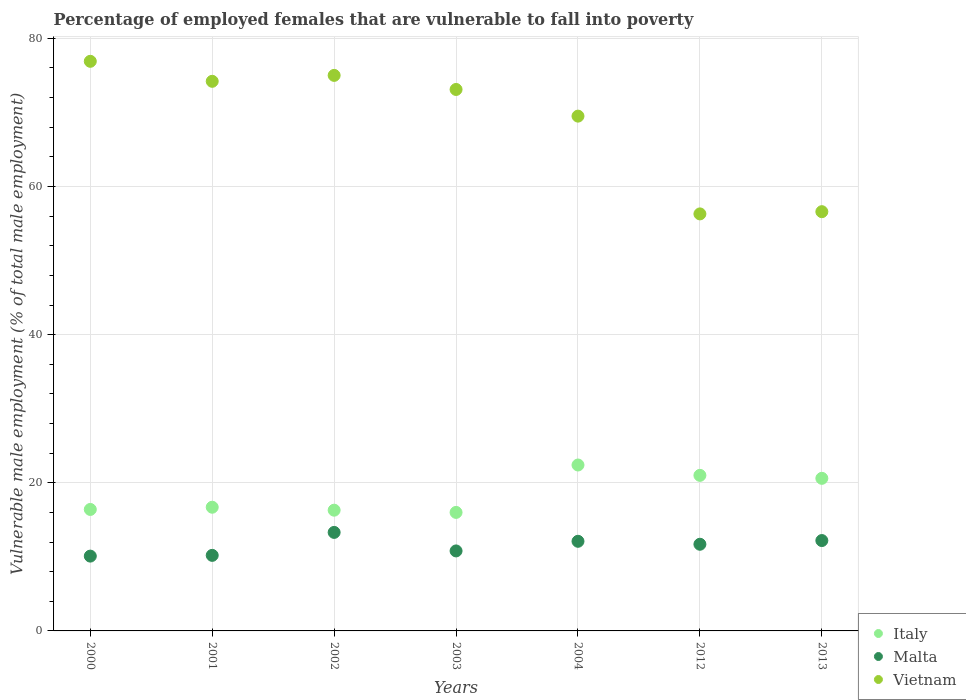What is the percentage of employed females who are vulnerable to fall into poverty in Italy in 2003?
Your response must be concise. 16. Across all years, what is the maximum percentage of employed females who are vulnerable to fall into poverty in Vietnam?
Give a very brief answer. 76.9. Across all years, what is the minimum percentage of employed females who are vulnerable to fall into poverty in Vietnam?
Offer a very short reply. 56.3. In which year was the percentage of employed females who are vulnerable to fall into poverty in Vietnam maximum?
Provide a short and direct response. 2000. In which year was the percentage of employed females who are vulnerable to fall into poverty in Malta minimum?
Your answer should be compact. 2000. What is the total percentage of employed females who are vulnerable to fall into poverty in Malta in the graph?
Ensure brevity in your answer.  80.4. What is the difference between the percentage of employed females who are vulnerable to fall into poverty in Malta in 2001 and that in 2013?
Ensure brevity in your answer.  -2. What is the difference between the percentage of employed females who are vulnerable to fall into poverty in Vietnam in 2013 and the percentage of employed females who are vulnerable to fall into poverty in Malta in 2000?
Your answer should be very brief. 46.5. What is the average percentage of employed females who are vulnerable to fall into poverty in Italy per year?
Offer a terse response. 18.49. In the year 2001, what is the difference between the percentage of employed females who are vulnerable to fall into poverty in Malta and percentage of employed females who are vulnerable to fall into poverty in Italy?
Your response must be concise. -6.5. In how many years, is the percentage of employed females who are vulnerable to fall into poverty in Vietnam greater than 24 %?
Give a very brief answer. 7. What is the ratio of the percentage of employed females who are vulnerable to fall into poverty in Italy in 2012 to that in 2013?
Offer a very short reply. 1.02. Is the percentage of employed females who are vulnerable to fall into poverty in Italy in 2012 less than that in 2013?
Offer a terse response. No. What is the difference between the highest and the second highest percentage of employed females who are vulnerable to fall into poverty in Italy?
Your answer should be compact. 1.4. What is the difference between the highest and the lowest percentage of employed females who are vulnerable to fall into poverty in Vietnam?
Give a very brief answer. 20.6. In how many years, is the percentage of employed females who are vulnerable to fall into poverty in Vietnam greater than the average percentage of employed females who are vulnerable to fall into poverty in Vietnam taken over all years?
Ensure brevity in your answer.  5. Is it the case that in every year, the sum of the percentage of employed females who are vulnerable to fall into poverty in Malta and percentage of employed females who are vulnerable to fall into poverty in Vietnam  is greater than the percentage of employed females who are vulnerable to fall into poverty in Italy?
Give a very brief answer. Yes. Does the percentage of employed females who are vulnerable to fall into poverty in Italy monotonically increase over the years?
Give a very brief answer. No. Is the percentage of employed females who are vulnerable to fall into poverty in Vietnam strictly less than the percentage of employed females who are vulnerable to fall into poverty in Malta over the years?
Keep it short and to the point. No. How many dotlines are there?
Give a very brief answer. 3. How many years are there in the graph?
Ensure brevity in your answer.  7. What is the difference between two consecutive major ticks on the Y-axis?
Provide a succinct answer. 20. Does the graph contain any zero values?
Make the answer very short. No. Does the graph contain grids?
Ensure brevity in your answer.  Yes. How many legend labels are there?
Offer a very short reply. 3. How are the legend labels stacked?
Ensure brevity in your answer.  Vertical. What is the title of the graph?
Offer a very short reply. Percentage of employed females that are vulnerable to fall into poverty. What is the label or title of the X-axis?
Make the answer very short. Years. What is the label or title of the Y-axis?
Give a very brief answer. Vulnerable male employment (% of total male employment). What is the Vulnerable male employment (% of total male employment) in Italy in 2000?
Make the answer very short. 16.4. What is the Vulnerable male employment (% of total male employment) of Malta in 2000?
Give a very brief answer. 10.1. What is the Vulnerable male employment (% of total male employment) of Vietnam in 2000?
Ensure brevity in your answer.  76.9. What is the Vulnerable male employment (% of total male employment) of Italy in 2001?
Offer a terse response. 16.7. What is the Vulnerable male employment (% of total male employment) of Malta in 2001?
Offer a terse response. 10.2. What is the Vulnerable male employment (% of total male employment) in Vietnam in 2001?
Keep it short and to the point. 74.2. What is the Vulnerable male employment (% of total male employment) in Italy in 2002?
Your answer should be compact. 16.3. What is the Vulnerable male employment (% of total male employment) of Malta in 2002?
Your answer should be compact. 13.3. What is the Vulnerable male employment (% of total male employment) of Vietnam in 2002?
Your response must be concise. 75. What is the Vulnerable male employment (% of total male employment) in Italy in 2003?
Ensure brevity in your answer.  16. What is the Vulnerable male employment (% of total male employment) of Malta in 2003?
Give a very brief answer. 10.8. What is the Vulnerable male employment (% of total male employment) of Vietnam in 2003?
Give a very brief answer. 73.1. What is the Vulnerable male employment (% of total male employment) of Italy in 2004?
Your response must be concise. 22.4. What is the Vulnerable male employment (% of total male employment) of Malta in 2004?
Your answer should be compact. 12.1. What is the Vulnerable male employment (% of total male employment) of Vietnam in 2004?
Offer a terse response. 69.5. What is the Vulnerable male employment (% of total male employment) in Italy in 2012?
Ensure brevity in your answer.  21. What is the Vulnerable male employment (% of total male employment) in Malta in 2012?
Your response must be concise. 11.7. What is the Vulnerable male employment (% of total male employment) of Vietnam in 2012?
Your answer should be very brief. 56.3. What is the Vulnerable male employment (% of total male employment) of Italy in 2013?
Provide a succinct answer. 20.6. What is the Vulnerable male employment (% of total male employment) in Malta in 2013?
Keep it short and to the point. 12.2. What is the Vulnerable male employment (% of total male employment) of Vietnam in 2013?
Provide a short and direct response. 56.6. Across all years, what is the maximum Vulnerable male employment (% of total male employment) in Italy?
Your response must be concise. 22.4. Across all years, what is the maximum Vulnerable male employment (% of total male employment) of Malta?
Give a very brief answer. 13.3. Across all years, what is the maximum Vulnerable male employment (% of total male employment) of Vietnam?
Offer a terse response. 76.9. Across all years, what is the minimum Vulnerable male employment (% of total male employment) of Malta?
Provide a short and direct response. 10.1. Across all years, what is the minimum Vulnerable male employment (% of total male employment) of Vietnam?
Your response must be concise. 56.3. What is the total Vulnerable male employment (% of total male employment) of Italy in the graph?
Your answer should be very brief. 129.4. What is the total Vulnerable male employment (% of total male employment) of Malta in the graph?
Offer a very short reply. 80.4. What is the total Vulnerable male employment (% of total male employment) in Vietnam in the graph?
Keep it short and to the point. 481.6. What is the difference between the Vulnerable male employment (% of total male employment) of Italy in 2000 and that in 2001?
Ensure brevity in your answer.  -0.3. What is the difference between the Vulnerable male employment (% of total male employment) of Vietnam in 2000 and that in 2001?
Your response must be concise. 2.7. What is the difference between the Vulnerable male employment (% of total male employment) of Italy in 2000 and that in 2002?
Your answer should be very brief. 0.1. What is the difference between the Vulnerable male employment (% of total male employment) in Italy in 2000 and that in 2003?
Keep it short and to the point. 0.4. What is the difference between the Vulnerable male employment (% of total male employment) of Malta in 2000 and that in 2003?
Ensure brevity in your answer.  -0.7. What is the difference between the Vulnerable male employment (% of total male employment) in Vietnam in 2000 and that in 2003?
Offer a terse response. 3.8. What is the difference between the Vulnerable male employment (% of total male employment) of Malta in 2000 and that in 2004?
Your answer should be compact. -2. What is the difference between the Vulnerable male employment (% of total male employment) in Italy in 2000 and that in 2012?
Your answer should be compact. -4.6. What is the difference between the Vulnerable male employment (% of total male employment) of Vietnam in 2000 and that in 2012?
Offer a terse response. 20.6. What is the difference between the Vulnerable male employment (% of total male employment) of Vietnam in 2000 and that in 2013?
Your answer should be compact. 20.3. What is the difference between the Vulnerable male employment (% of total male employment) in Italy in 2001 and that in 2002?
Your answer should be compact. 0.4. What is the difference between the Vulnerable male employment (% of total male employment) in Vietnam in 2001 and that in 2002?
Provide a succinct answer. -0.8. What is the difference between the Vulnerable male employment (% of total male employment) of Italy in 2001 and that in 2003?
Make the answer very short. 0.7. What is the difference between the Vulnerable male employment (% of total male employment) in Vietnam in 2001 and that in 2003?
Offer a very short reply. 1.1. What is the difference between the Vulnerable male employment (% of total male employment) of Malta in 2001 and that in 2004?
Ensure brevity in your answer.  -1.9. What is the difference between the Vulnerable male employment (% of total male employment) of Vietnam in 2001 and that in 2012?
Make the answer very short. 17.9. What is the difference between the Vulnerable male employment (% of total male employment) in Italy in 2001 and that in 2013?
Provide a short and direct response. -3.9. What is the difference between the Vulnerable male employment (% of total male employment) of Malta in 2001 and that in 2013?
Ensure brevity in your answer.  -2. What is the difference between the Vulnerable male employment (% of total male employment) in Italy in 2002 and that in 2003?
Offer a very short reply. 0.3. What is the difference between the Vulnerable male employment (% of total male employment) of Vietnam in 2002 and that in 2003?
Give a very brief answer. 1.9. What is the difference between the Vulnerable male employment (% of total male employment) of Italy in 2002 and that in 2004?
Give a very brief answer. -6.1. What is the difference between the Vulnerable male employment (% of total male employment) of Vietnam in 2002 and that in 2012?
Ensure brevity in your answer.  18.7. What is the difference between the Vulnerable male employment (% of total male employment) in Italy in 2002 and that in 2013?
Your response must be concise. -4.3. What is the difference between the Vulnerable male employment (% of total male employment) in Malta in 2002 and that in 2013?
Offer a very short reply. 1.1. What is the difference between the Vulnerable male employment (% of total male employment) of Vietnam in 2002 and that in 2013?
Your answer should be compact. 18.4. What is the difference between the Vulnerable male employment (% of total male employment) of Italy in 2003 and that in 2004?
Your answer should be compact. -6.4. What is the difference between the Vulnerable male employment (% of total male employment) in Malta in 2003 and that in 2004?
Your response must be concise. -1.3. What is the difference between the Vulnerable male employment (% of total male employment) of Vietnam in 2003 and that in 2012?
Your answer should be compact. 16.8. What is the difference between the Vulnerable male employment (% of total male employment) in Italy in 2003 and that in 2013?
Your response must be concise. -4.6. What is the difference between the Vulnerable male employment (% of total male employment) of Malta in 2003 and that in 2013?
Your response must be concise. -1.4. What is the difference between the Vulnerable male employment (% of total male employment) of Vietnam in 2003 and that in 2013?
Provide a succinct answer. 16.5. What is the difference between the Vulnerable male employment (% of total male employment) of Malta in 2004 and that in 2012?
Ensure brevity in your answer.  0.4. What is the difference between the Vulnerable male employment (% of total male employment) of Italy in 2004 and that in 2013?
Your answer should be very brief. 1.8. What is the difference between the Vulnerable male employment (% of total male employment) in Vietnam in 2004 and that in 2013?
Make the answer very short. 12.9. What is the difference between the Vulnerable male employment (% of total male employment) of Malta in 2012 and that in 2013?
Give a very brief answer. -0.5. What is the difference between the Vulnerable male employment (% of total male employment) of Vietnam in 2012 and that in 2013?
Your response must be concise. -0.3. What is the difference between the Vulnerable male employment (% of total male employment) of Italy in 2000 and the Vulnerable male employment (% of total male employment) of Malta in 2001?
Give a very brief answer. 6.2. What is the difference between the Vulnerable male employment (% of total male employment) in Italy in 2000 and the Vulnerable male employment (% of total male employment) in Vietnam in 2001?
Your answer should be very brief. -57.8. What is the difference between the Vulnerable male employment (% of total male employment) in Malta in 2000 and the Vulnerable male employment (% of total male employment) in Vietnam in 2001?
Offer a terse response. -64.1. What is the difference between the Vulnerable male employment (% of total male employment) in Italy in 2000 and the Vulnerable male employment (% of total male employment) in Malta in 2002?
Provide a succinct answer. 3.1. What is the difference between the Vulnerable male employment (% of total male employment) of Italy in 2000 and the Vulnerable male employment (% of total male employment) of Vietnam in 2002?
Offer a very short reply. -58.6. What is the difference between the Vulnerable male employment (% of total male employment) in Malta in 2000 and the Vulnerable male employment (% of total male employment) in Vietnam in 2002?
Ensure brevity in your answer.  -64.9. What is the difference between the Vulnerable male employment (% of total male employment) of Italy in 2000 and the Vulnerable male employment (% of total male employment) of Malta in 2003?
Your answer should be very brief. 5.6. What is the difference between the Vulnerable male employment (% of total male employment) of Italy in 2000 and the Vulnerable male employment (% of total male employment) of Vietnam in 2003?
Provide a succinct answer. -56.7. What is the difference between the Vulnerable male employment (% of total male employment) in Malta in 2000 and the Vulnerable male employment (% of total male employment) in Vietnam in 2003?
Provide a short and direct response. -63. What is the difference between the Vulnerable male employment (% of total male employment) in Italy in 2000 and the Vulnerable male employment (% of total male employment) in Vietnam in 2004?
Give a very brief answer. -53.1. What is the difference between the Vulnerable male employment (% of total male employment) of Malta in 2000 and the Vulnerable male employment (% of total male employment) of Vietnam in 2004?
Provide a succinct answer. -59.4. What is the difference between the Vulnerable male employment (% of total male employment) in Italy in 2000 and the Vulnerable male employment (% of total male employment) in Malta in 2012?
Ensure brevity in your answer.  4.7. What is the difference between the Vulnerable male employment (% of total male employment) of Italy in 2000 and the Vulnerable male employment (% of total male employment) of Vietnam in 2012?
Give a very brief answer. -39.9. What is the difference between the Vulnerable male employment (% of total male employment) of Malta in 2000 and the Vulnerable male employment (% of total male employment) of Vietnam in 2012?
Your answer should be very brief. -46.2. What is the difference between the Vulnerable male employment (% of total male employment) of Italy in 2000 and the Vulnerable male employment (% of total male employment) of Vietnam in 2013?
Provide a succinct answer. -40.2. What is the difference between the Vulnerable male employment (% of total male employment) in Malta in 2000 and the Vulnerable male employment (% of total male employment) in Vietnam in 2013?
Make the answer very short. -46.5. What is the difference between the Vulnerable male employment (% of total male employment) of Italy in 2001 and the Vulnerable male employment (% of total male employment) of Vietnam in 2002?
Offer a very short reply. -58.3. What is the difference between the Vulnerable male employment (% of total male employment) of Malta in 2001 and the Vulnerable male employment (% of total male employment) of Vietnam in 2002?
Your answer should be compact. -64.8. What is the difference between the Vulnerable male employment (% of total male employment) in Italy in 2001 and the Vulnerable male employment (% of total male employment) in Malta in 2003?
Your response must be concise. 5.9. What is the difference between the Vulnerable male employment (% of total male employment) of Italy in 2001 and the Vulnerable male employment (% of total male employment) of Vietnam in 2003?
Give a very brief answer. -56.4. What is the difference between the Vulnerable male employment (% of total male employment) of Malta in 2001 and the Vulnerable male employment (% of total male employment) of Vietnam in 2003?
Offer a terse response. -62.9. What is the difference between the Vulnerable male employment (% of total male employment) in Italy in 2001 and the Vulnerable male employment (% of total male employment) in Vietnam in 2004?
Make the answer very short. -52.8. What is the difference between the Vulnerable male employment (% of total male employment) of Malta in 2001 and the Vulnerable male employment (% of total male employment) of Vietnam in 2004?
Give a very brief answer. -59.3. What is the difference between the Vulnerable male employment (% of total male employment) of Italy in 2001 and the Vulnerable male employment (% of total male employment) of Malta in 2012?
Provide a succinct answer. 5. What is the difference between the Vulnerable male employment (% of total male employment) in Italy in 2001 and the Vulnerable male employment (% of total male employment) in Vietnam in 2012?
Your response must be concise. -39.6. What is the difference between the Vulnerable male employment (% of total male employment) of Malta in 2001 and the Vulnerable male employment (% of total male employment) of Vietnam in 2012?
Your response must be concise. -46.1. What is the difference between the Vulnerable male employment (% of total male employment) in Italy in 2001 and the Vulnerable male employment (% of total male employment) in Vietnam in 2013?
Your response must be concise. -39.9. What is the difference between the Vulnerable male employment (% of total male employment) of Malta in 2001 and the Vulnerable male employment (% of total male employment) of Vietnam in 2013?
Ensure brevity in your answer.  -46.4. What is the difference between the Vulnerable male employment (% of total male employment) of Italy in 2002 and the Vulnerable male employment (% of total male employment) of Vietnam in 2003?
Make the answer very short. -56.8. What is the difference between the Vulnerable male employment (% of total male employment) of Malta in 2002 and the Vulnerable male employment (% of total male employment) of Vietnam in 2003?
Ensure brevity in your answer.  -59.8. What is the difference between the Vulnerable male employment (% of total male employment) in Italy in 2002 and the Vulnerable male employment (% of total male employment) in Malta in 2004?
Your response must be concise. 4.2. What is the difference between the Vulnerable male employment (% of total male employment) of Italy in 2002 and the Vulnerable male employment (% of total male employment) of Vietnam in 2004?
Make the answer very short. -53.2. What is the difference between the Vulnerable male employment (% of total male employment) of Malta in 2002 and the Vulnerable male employment (% of total male employment) of Vietnam in 2004?
Ensure brevity in your answer.  -56.2. What is the difference between the Vulnerable male employment (% of total male employment) of Italy in 2002 and the Vulnerable male employment (% of total male employment) of Malta in 2012?
Give a very brief answer. 4.6. What is the difference between the Vulnerable male employment (% of total male employment) in Malta in 2002 and the Vulnerable male employment (% of total male employment) in Vietnam in 2012?
Ensure brevity in your answer.  -43. What is the difference between the Vulnerable male employment (% of total male employment) in Italy in 2002 and the Vulnerable male employment (% of total male employment) in Malta in 2013?
Offer a very short reply. 4.1. What is the difference between the Vulnerable male employment (% of total male employment) in Italy in 2002 and the Vulnerable male employment (% of total male employment) in Vietnam in 2013?
Make the answer very short. -40.3. What is the difference between the Vulnerable male employment (% of total male employment) in Malta in 2002 and the Vulnerable male employment (% of total male employment) in Vietnam in 2013?
Provide a succinct answer. -43.3. What is the difference between the Vulnerable male employment (% of total male employment) in Italy in 2003 and the Vulnerable male employment (% of total male employment) in Malta in 2004?
Provide a short and direct response. 3.9. What is the difference between the Vulnerable male employment (% of total male employment) of Italy in 2003 and the Vulnerable male employment (% of total male employment) of Vietnam in 2004?
Make the answer very short. -53.5. What is the difference between the Vulnerable male employment (% of total male employment) of Malta in 2003 and the Vulnerable male employment (% of total male employment) of Vietnam in 2004?
Offer a very short reply. -58.7. What is the difference between the Vulnerable male employment (% of total male employment) of Italy in 2003 and the Vulnerable male employment (% of total male employment) of Vietnam in 2012?
Offer a terse response. -40.3. What is the difference between the Vulnerable male employment (% of total male employment) of Malta in 2003 and the Vulnerable male employment (% of total male employment) of Vietnam in 2012?
Provide a succinct answer. -45.5. What is the difference between the Vulnerable male employment (% of total male employment) of Italy in 2003 and the Vulnerable male employment (% of total male employment) of Vietnam in 2013?
Provide a short and direct response. -40.6. What is the difference between the Vulnerable male employment (% of total male employment) of Malta in 2003 and the Vulnerable male employment (% of total male employment) of Vietnam in 2013?
Provide a short and direct response. -45.8. What is the difference between the Vulnerable male employment (% of total male employment) in Italy in 2004 and the Vulnerable male employment (% of total male employment) in Vietnam in 2012?
Your answer should be very brief. -33.9. What is the difference between the Vulnerable male employment (% of total male employment) of Malta in 2004 and the Vulnerable male employment (% of total male employment) of Vietnam in 2012?
Provide a succinct answer. -44.2. What is the difference between the Vulnerable male employment (% of total male employment) in Italy in 2004 and the Vulnerable male employment (% of total male employment) in Malta in 2013?
Keep it short and to the point. 10.2. What is the difference between the Vulnerable male employment (% of total male employment) in Italy in 2004 and the Vulnerable male employment (% of total male employment) in Vietnam in 2013?
Keep it short and to the point. -34.2. What is the difference between the Vulnerable male employment (% of total male employment) of Malta in 2004 and the Vulnerable male employment (% of total male employment) of Vietnam in 2013?
Ensure brevity in your answer.  -44.5. What is the difference between the Vulnerable male employment (% of total male employment) of Italy in 2012 and the Vulnerable male employment (% of total male employment) of Malta in 2013?
Your answer should be very brief. 8.8. What is the difference between the Vulnerable male employment (% of total male employment) in Italy in 2012 and the Vulnerable male employment (% of total male employment) in Vietnam in 2013?
Keep it short and to the point. -35.6. What is the difference between the Vulnerable male employment (% of total male employment) of Malta in 2012 and the Vulnerable male employment (% of total male employment) of Vietnam in 2013?
Your answer should be very brief. -44.9. What is the average Vulnerable male employment (% of total male employment) in Italy per year?
Offer a terse response. 18.49. What is the average Vulnerable male employment (% of total male employment) in Malta per year?
Make the answer very short. 11.49. What is the average Vulnerable male employment (% of total male employment) of Vietnam per year?
Provide a short and direct response. 68.8. In the year 2000, what is the difference between the Vulnerable male employment (% of total male employment) in Italy and Vulnerable male employment (% of total male employment) in Malta?
Provide a short and direct response. 6.3. In the year 2000, what is the difference between the Vulnerable male employment (% of total male employment) of Italy and Vulnerable male employment (% of total male employment) of Vietnam?
Provide a short and direct response. -60.5. In the year 2000, what is the difference between the Vulnerable male employment (% of total male employment) of Malta and Vulnerable male employment (% of total male employment) of Vietnam?
Your answer should be compact. -66.8. In the year 2001, what is the difference between the Vulnerable male employment (% of total male employment) of Italy and Vulnerable male employment (% of total male employment) of Vietnam?
Offer a very short reply. -57.5. In the year 2001, what is the difference between the Vulnerable male employment (% of total male employment) of Malta and Vulnerable male employment (% of total male employment) of Vietnam?
Make the answer very short. -64. In the year 2002, what is the difference between the Vulnerable male employment (% of total male employment) in Italy and Vulnerable male employment (% of total male employment) in Vietnam?
Ensure brevity in your answer.  -58.7. In the year 2002, what is the difference between the Vulnerable male employment (% of total male employment) of Malta and Vulnerable male employment (% of total male employment) of Vietnam?
Offer a very short reply. -61.7. In the year 2003, what is the difference between the Vulnerable male employment (% of total male employment) of Italy and Vulnerable male employment (% of total male employment) of Vietnam?
Provide a short and direct response. -57.1. In the year 2003, what is the difference between the Vulnerable male employment (% of total male employment) of Malta and Vulnerable male employment (% of total male employment) of Vietnam?
Your answer should be compact. -62.3. In the year 2004, what is the difference between the Vulnerable male employment (% of total male employment) of Italy and Vulnerable male employment (% of total male employment) of Vietnam?
Your answer should be compact. -47.1. In the year 2004, what is the difference between the Vulnerable male employment (% of total male employment) in Malta and Vulnerable male employment (% of total male employment) in Vietnam?
Keep it short and to the point. -57.4. In the year 2012, what is the difference between the Vulnerable male employment (% of total male employment) in Italy and Vulnerable male employment (% of total male employment) in Vietnam?
Your answer should be very brief. -35.3. In the year 2012, what is the difference between the Vulnerable male employment (% of total male employment) in Malta and Vulnerable male employment (% of total male employment) in Vietnam?
Offer a very short reply. -44.6. In the year 2013, what is the difference between the Vulnerable male employment (% of total male employment) of Italy and Vulnerable male employment (% of total male employment) of Vietnam?
Your response must be concise. -36. In the year 2013, what is the difference between the Vulnerable male employment (% of total male employment) of Malta and Vulnerable male employment (% of total male employment) of Vietnam?
Offer a terse response. -44.4. What is the ratio of the Vulnerable male employment (% of total male employment) of Malta in 2000 to that in 2001?
Give a very brief answer. 0.99. What is the ratio of the Vulnerable male employment (% of total male employment) of Vietnam in 2000 to that in 2001?
Provide a short and direct response. 1.04. What is the ratio of the Vulnerable male employment (% of total male employment) in Italy in 2000 to that in 2002?
Make the answer very short. 1.01. What is the ratio of the Vulnerable male employment (% of total male employment) in Malta in 2000 to that in 2002?
Your answer should be very brief. 0.76. What is the ratio of the Vulnerable male employment (% of total male employment) in Vietnam in 2000 to that in 2002?
Make the answer very short. 1.03. What is the ratio of the Vulnerable male employment (% of total male employment) in Italy in 2000 to that in 2003?
Make the answer very short. 1.02. What is the ratio of the Vulnerable male employment (% of total male employment) in Malta in 2000 to that in 2003?
Provide a succinct answer. 0.94. What is the ratio of the Vulnerable male employment (% of total male employment) of Vietnam in 2000 to that in 2003?
Give a very brief answer. 1.05. What is the ratio of the Vulnerable male employment (% of total male employment) of Italy in 2000 to that in 2004?
Offer a very short reply. 0.73. What is the ratio of the Vulnerable male employment (% of total male employment) in Malta in 2000 to that in 2004?
Your response must be concise. 0.83. What is the ratio of the Vulnerable male employment (% of total male employment) of Vietnam in 2000 to that in 2004?
Offer a very short reply. 1.11. What is the ratio of the Vulnerable male employment (% of total male employment) in Italy in 2000 to that in 2012?
Keep it short and to the point. 0.78. What is the ratio of the Vulnerable male employment (% of total male employment) in Malta in 2000 to that in 2012?
Keep it short and to the point. 0.86. What is the ratio of the Vulnerable male employment (% of total male employment) of Vietnam in 2000 to that in 2012?
Make the answer very short. 1.37. What is the ratio of the Vulnerable male employment (% of total male employment) of Italy in 2000 to that in 2013?
Your answer should be very brief. 0.8. What is the ratio of the Vulnerable male employment (% of total male employment) of Malta in 2000 to that in 2013?
Make the answer very short. 0.83. What is the ratio of the Vulnerable male employment (% of total male employment) in Vietnam in 2000 to that in 2013?
Ensure brevity in your answer.  1.36. What is the ratio of the Vulnerable male employment (% of total male employment) of Italy in 2001 to that in 2002?
Make the answer very short. 1.02. What is the ratio of the Vulnerable male employment (% of total male employment) in Malta in 2001 to that in 2002?
Offer a terse response. 0.77. What is the ratio of the Vulnerable male employment (% of total male employment) of Vietnam in 2001 to that in 2002?
Provide a succinct answer. 0.99. What is the ratio of the Vulnerable male employment (% of total male employment) in Italy in 2001 to that in 2003?
Your response must be concise. 1.04. What is the ratio of the Vulnerable male employment (% of total male employment) in Vietnam in 2001 to that in 2003?
Offer a terse response. 1.01. What is the ratio of the Vulnerable male employment (% of total male employment) in Italy in 2001 to that in 2004?
Your response must be concise. 0.75. What is the ratio of the Vulnerable male employment (% of total male employment) in Malta in 2001 to that in 2004?
Provide a short and direct response. 0.84. What is the ratio of the Vulnerable male employment (% of total male employment) of Vietnam in 2001 to that in 2004?
Your answer should be very brief. 1.07. What is the ratio of the Vulnerable male employment (% of total male employment) of Italy in 2001 to that in 2012?
Your answer should be very brief. 0.8. What is the ratio of the Vulnerable male employment (% of total male employment) of Malta in 2001 to that in 2012?
Your answer should be compact. 0.87. What is the ratio of the Vulnerable male employment (% of total male employment) in Vietnam in 2001 to that in 2012?
Provide a succinct answer. 1.32. What is the ratio of the Vulnerable male employment (% of total male employment) in Italy in 2001 to that in 2013?
Your answer should be very brief. 0.81. What is the ratio of the Vulnerable male employment (% of total male employment) in Malta in 2001 to that in 2013?
Ensure brevity in your answer.  0.84. What is the ratio of the Vulnerable male employment (% of total male employment) of Vietnam in 2001 to that in 2013?
Give a very brief answer. 1.31. What is the ratio of the Vulnerable male employment (% of total male employment) in Italy in 2002 to that in 2003?
Offer a very short reply. 1.02. What is the ratio of the Vulnerable male employment (% of total male employment) in Malta in 2002 to that in 2003?
Keep it short and to the point. 1.23. What is the ratio of the Vulnerable male employment (% of total male employment) of Vietnam in 2002 to that in 2003?
Your answer should be very brief. 1.03. What is the ratio of the Vulnerable male employment (% of total male employment) of Italy in 2002 to that in 2004?
Provide a short and direct response. 0.73. What is the ratio of the Vulnerable male employment (% of total male employment) of Malta in 2002 to that in 2004?
Provide a succinct answer. 1.1. What is the ratio of the Vulnerable male employment (% of total male employment) of Vietnam in 2002 to that in 2004?
Your answer should be compact. 1.08. What is the ratio of the Vulnerable male employment (% of total male employment) in Italy in 2002 to that in 2012?
Offer a very short reply. 0.78. What is the ratio of the Vulnerable male employment (% of total male employment) in Malta in 2002 to that in 2012?
Make the answer very short. 1.14. What is the ratio of the Vulnerable male employment (% of total male employment) of Vietnam in 2002 to that in 2012?
Your answer should be compact. 1.33. What is the ratio of the Vulnerable male employment (% of total male employment) in Italy in 2002 to that in 2013?
Make the answer very short. 0.79. What is the ratio of the Vulnerable male employment (% of total male employment) in Malta in 2002 to that in 2013?
Make the answer very short. 1.09. What is the ratio of the Vulnerable male employment (% of total male employment) in Vietnam in 2002 to that in 2013?
Offer a very short reply. 1.33. What is the ratio of the Vulnerable male employment (% of total male employment) of Italy in 2003 to that in 2004?
Offer a terse response. 0.71. What is the ratio of the Vulnerable male employment (% of total male employment) in Malta in 2003 to that in 2004?
Ensure brevity in your answer.  0.89. What is the ratio of the Vulnerable male employment (% of total male employment) of Vietnam in 2003 to that in 2004?
Provide a short and direct response. 1.05. What is the ratio of the Vulnerable male employment (% of total male employment) in Italy in 2003 to that in 2012?
Ensure brevity in your answer.  0.76. What is the ratio of the Vulnerable male employment (% of total male employment) of Vietnam in 2003 to that in 2012?
Your answer should be compact. 1.3. What is the ratio of the Vulnerable male employment (% of total male employment) in Italy in 2003 to that in 2013?
Offer a terse response. 0.78. What is the ratio of the Vulnerable male employment (% of total male employment) in Malta in 2003 to that in 2013?
Your response must be concise. 0.89. What is the ratio of the Vulnerable male employment (% of total male employment) in Vietnam in 2003 to that in 2013?
Provide a short and direct response. 1.29. What is the ratio of the Vulnerable male employment (% of total male employment) of Italy in 2004 to that in 2012?
Your response must be concise. 1.07. What is the ratio of the Vulnerable male employment (% of total male employment) of Malta in 2004 to that in 2012?
Your answer should be very brief. 1.03. What is the ratio of the Vulnerable male employment (% of total male employment) in Vietnam in 2004 to that in 2012?
Provide a succinct answer. 1.23. What is the ratio of the Vulnerable male employment (% of total male employment) of Italy in 2004 to that in 2013?
Keep it short and to the point. 1.09. What is the ratio of the Vulnerable male employment (% of total male employment) of Vietnam in 2004 to that in 2013?
Provide a short and direct response. 1.23. What is the ratio of the Vulnerable male employment (% of total male employment) in Italy in 2012 to that in 2013?
Make the answer very short. 1.02. What is the ratio of the Vulnerable male employment (% of total male employment) in Vietnam in 2012 to that in 2013?
Keep it short and to the point. 0.99. What is the difference between the highest and the second highest Vulnerable male employment (% of total male employment) of Vietnam?
Your response must be concise. 1.9. What is the difference between the highest and the lowest Vulnerable male employment (% of total male employment) in Malta?
Provide a succinct answer. 3.2. What is the difference between the highest and the lowest Vulnerable male employment (% of total male employment) of Vietnam?
Ensure brevity in your answer.  20.6. 